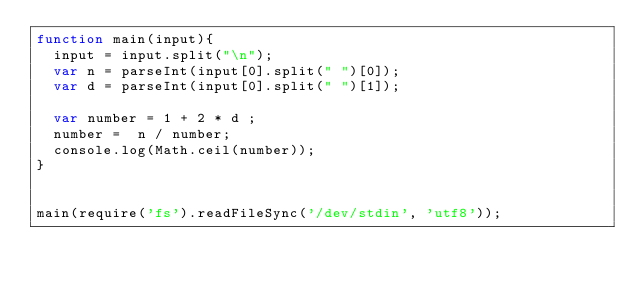<code> <loc_0><loc_0><loc_500><loc_500><_JavaScript_>function main(input){
  input = input.split("\n");
  var n = parseInt(input[0].split(" ")[0]);
  var d = parseInt(input[0].split(" ")[1]);

  var number = 1 + 2 * d ;
  number =  n / number; 
  console.log(Math.ceil(number));
}
 
 
main(require('fs').readFileSync('/dev/stdin', 'utf8'));</code> 